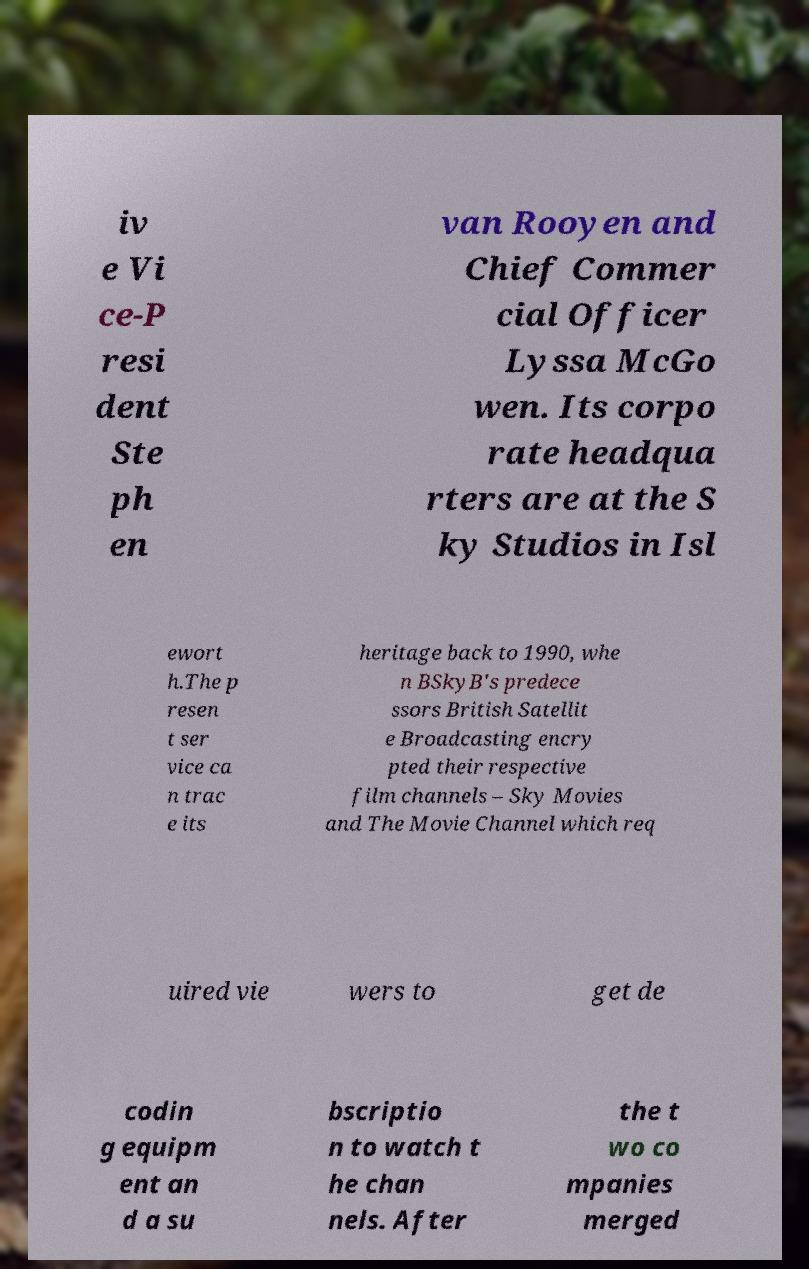Please identify and transcribe the text found in this image. iv e Vi ce-P resi dent Ste ph en van Rooyen and Chief Commer cial Officer Lyssa McGo wen. Its corpo rate headqua rters are at the S ky Studios in Isl ewort h.The p resen t ser vice ca n trac e its heritage back to 1990, whe n BSkyB's predece ssors British Satellit e Broadcasting encry pted their respective film channels – Sky Movies and The Movie Channel which req uired vie wers to get de codin g equipm ent an d a su bscriptio n to watch t he chan nels. After the t wo co mpanies merged 